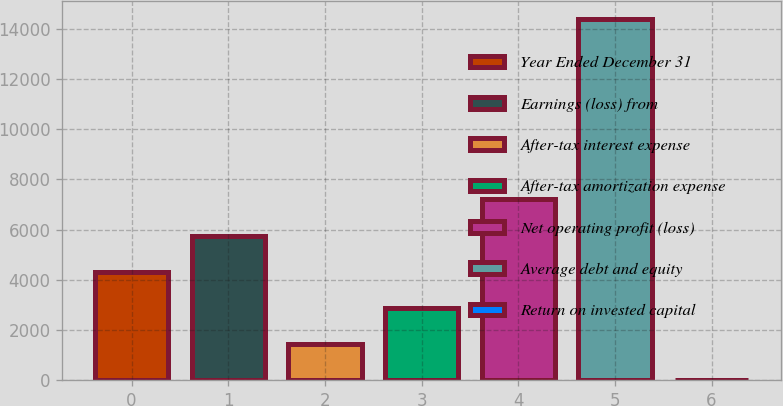Convert chart. <chart><loc_0><loc_0><loc_500><loc_500><bar_chart><fcel>Year Ended December 31<fcel>Earnings (loss) from<fcel>After-tax interest expense<fcel>After-tax amortization expense<fcel>Net operating profit (loss)<fcel>Average debt and equity<fcel>Return on invested capital<nl><fcel>4329.95<fcel>5767.1<fcel>1455.65<fcel>2892.8<fcel>7204.25<fcel>14390<fcel>18.5<nl></chart> 